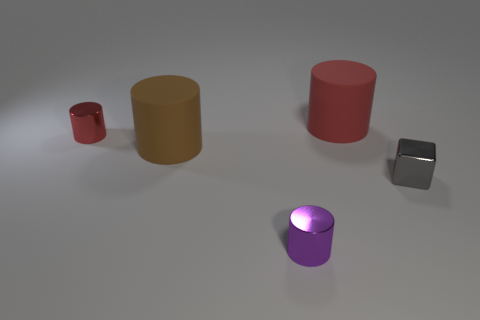What number of other things are the same material as the tiny purple thing?
Your response must be concise. 2. What number of rubber things are either tiny red cylinders or small blue cubes?
Provide a short and direct response. 0. There is a purple shiny object in front of the brown rubber object; is its shape the same as the tiny gray metal thing?
Offer a very short reply. No. Are there more blocks on the left side of the small red object than big cylinders?
Your response must be concise. No. How many objects are both in front of the small red cylinder and behind the small gray metallic object?
Keep it short and to the point. 1. There is a big matte thing that is on the left side of the cylinder to the right of the purple object; what is its color?
Your answer should be very brief. Brown. How many large matte things have the same color as the small metallic cube?
Your answer should be very brief. 0. There is a tiny metallic block; is it the same color as the big rubber cylinder that is in front of the tiny red thing?
Keep it short and to the point. No. Is the number of red metallic objects less than the number of objects?
Ensure brevity in your answer.  Yes. Are there more shiny cylinders that are behind the small purple object than small red objects to the right of the small gray metal object?
Your answer should be compact. Yes. 